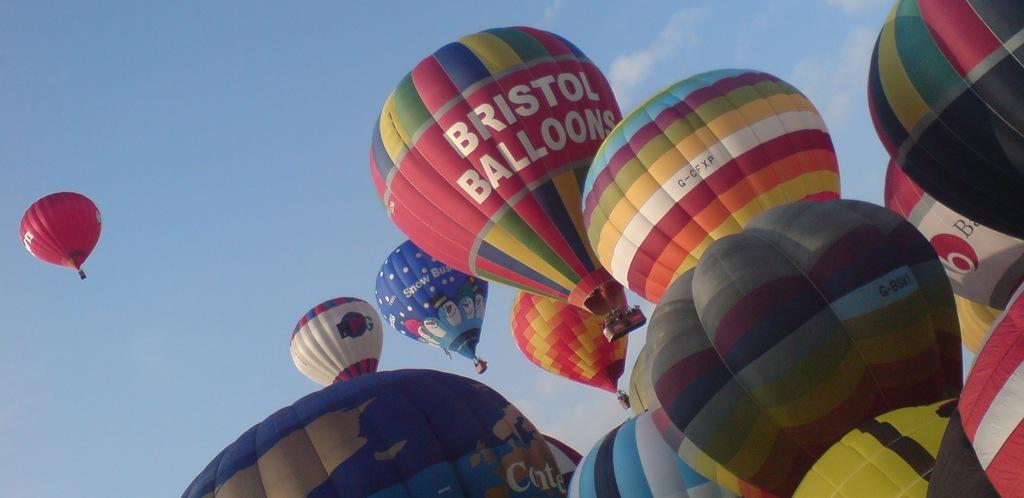What is the main subject of the image? The main subject of the image is air balloons. Where are the air balloons located? The air balloons are in the air. What can be seen on the air balloons? There is writing on the air balloons. What is visible in the background of the image? Clouds and the sky are visible in the background of the image. What type of cabbage is being used to power the air balloons in the image? There is no cabbage present in the image, and the air balloons are not powered by any type of cabbage. 